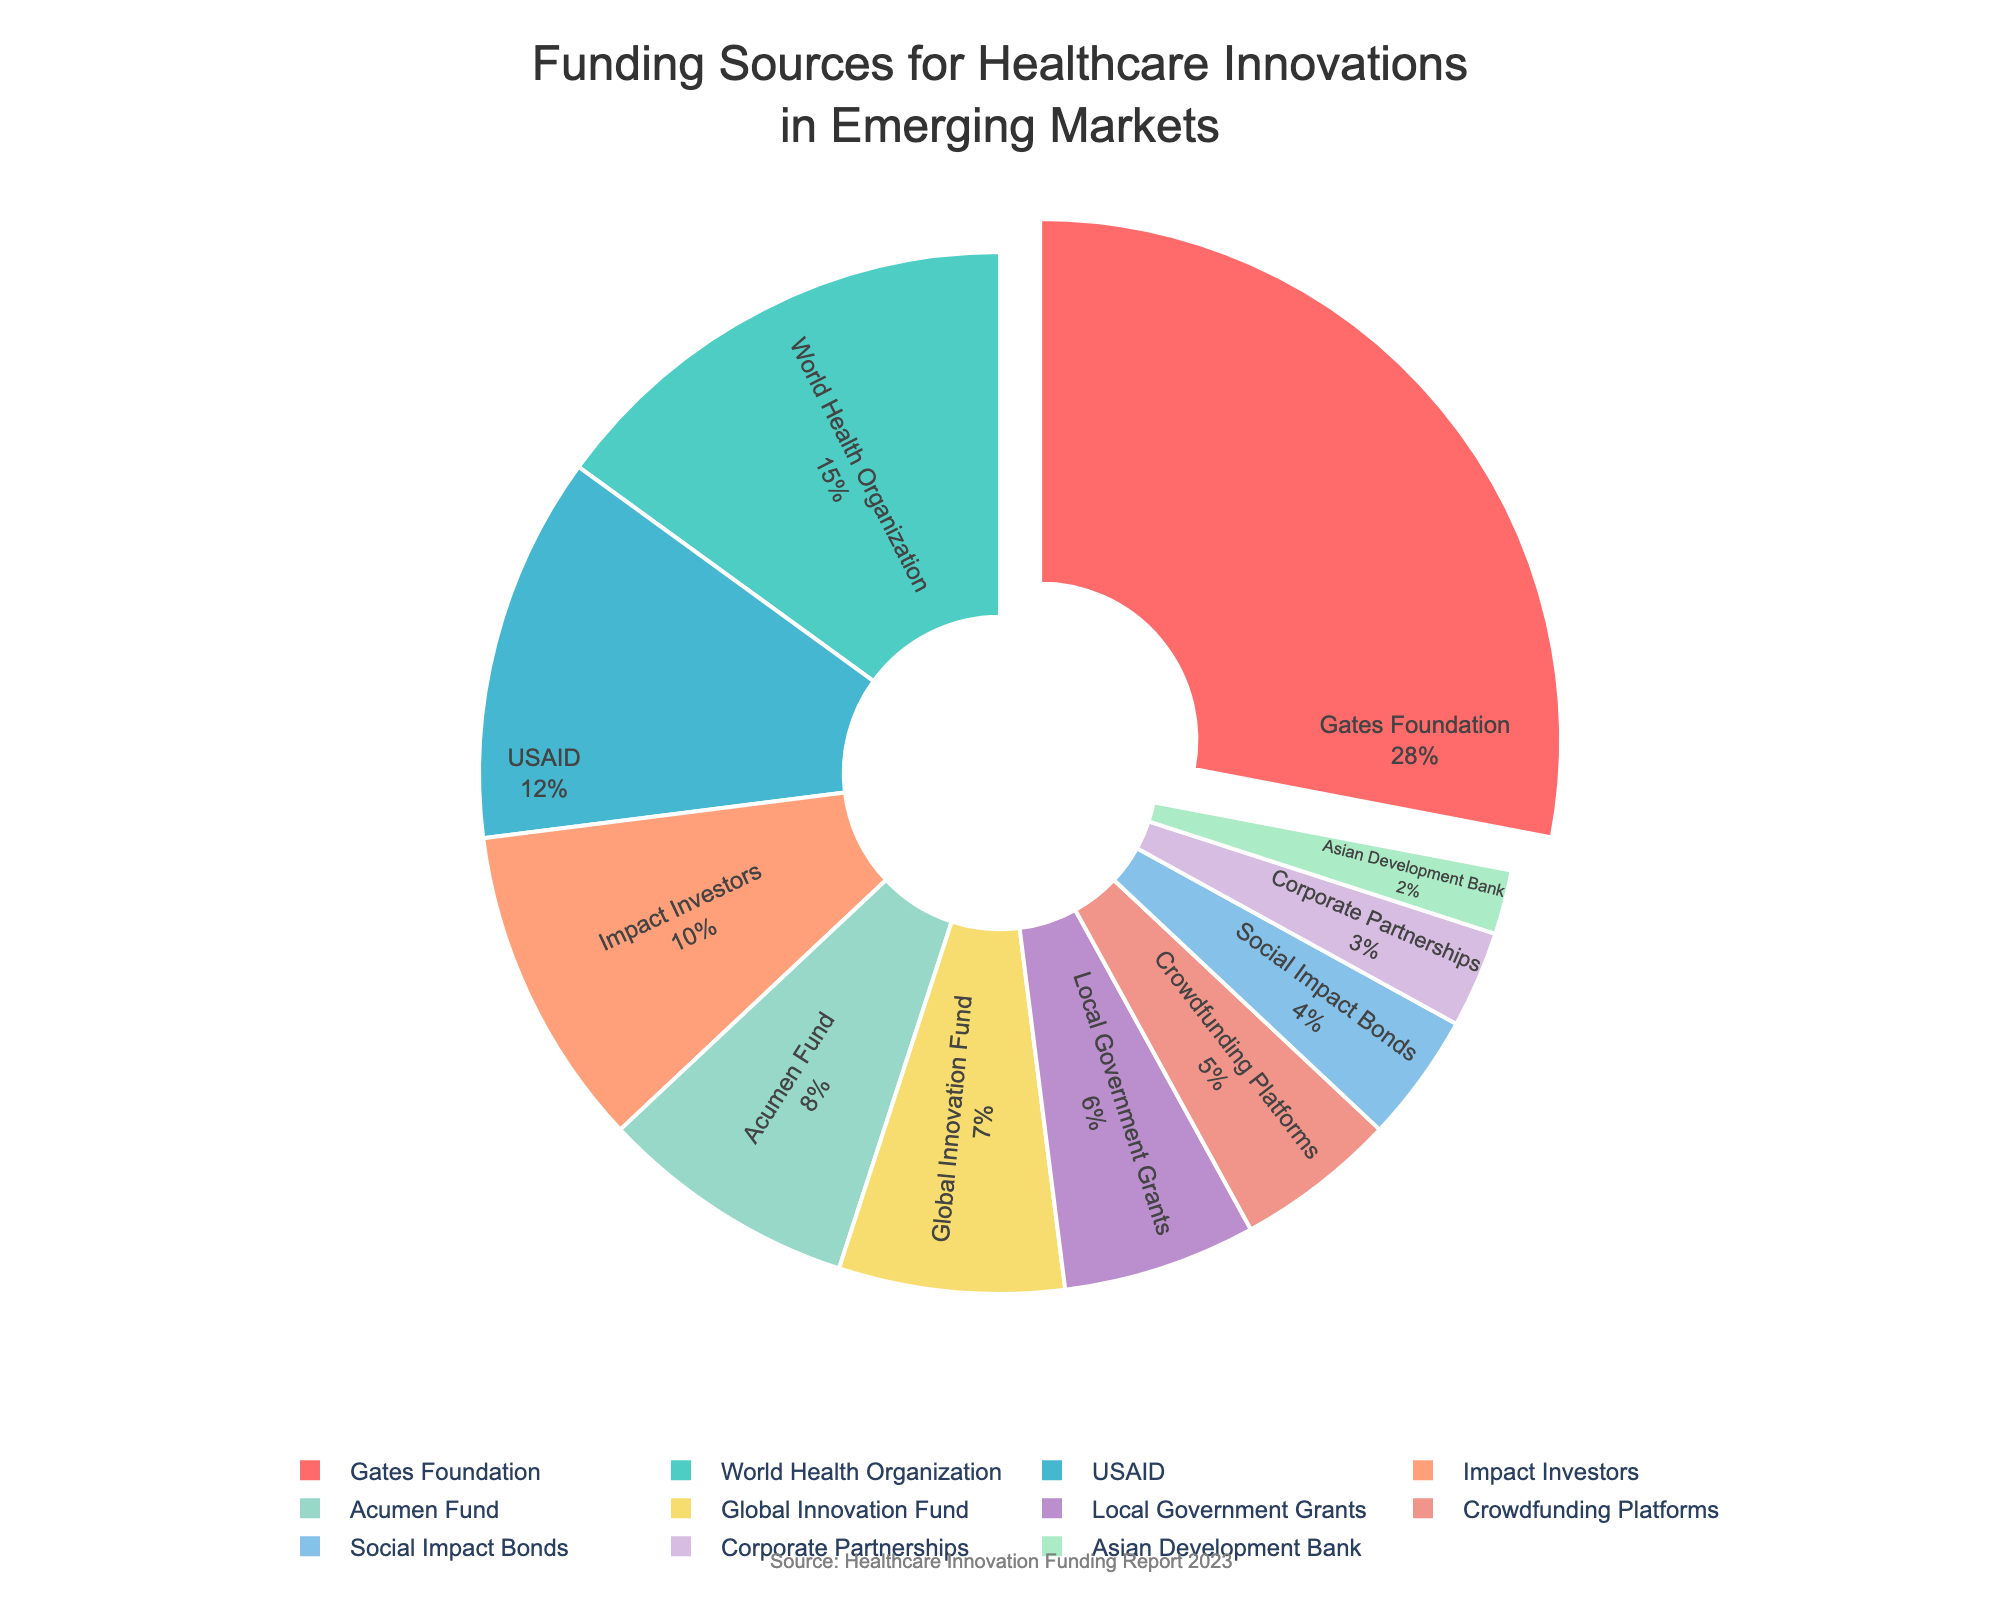What percentage of funding comes from the top three sources? To answer this, add the percentages for the top three funding sources: Gates Foundation (28%), World Health Organization (15%), and USAID (12%). The sum is 28 + 15 + 12 = 55%.
Answer: 55% Which funding source provides the least amount of funding? Look at the chart and identify the funding source with the smallest percentage. The Asian Development Bank has 2%, which is the smallest.
Answer: Asian Development Bank How much more funding does the Gates Foundation provide compared to Social Impact Bonds? Subtract the percentage of Social Impact Bonds from the percentage of Gates Foundation: 28% - 4% = 24%.
Answer: 24% What is the percentage of funding provided by non-governmental organizations (Gates Foundation, World Health Organization, USAID, Impact Investors, Acumen Fund)? Sum the percentages of these organizations: Gates Foundation (28%), World Health Organization (15%), USAID (12%), Impact Investors (10%), and Acumen Fund (8%). The total is 28 + 15 + 12 + 10 + 8 = 73%.
Answer: 73% If the total funding is $100 million, how much does the Global Innovation Fund contribute? Use the percentage for the Global Innovation Fund (7%). Calculate 7% of $100 million: 0.07 * 100,000,000 = $7,000,000.
Answer: $7,000,000 Which color represents the funding from Crowdfunding Platforms, and what percentage do they contribute? The color associated with Crowdfunding Platforms is observed to be a shade that matches the provided color scheme, which is '#F1948A'. The percentage is 5%.
Answer: Pink, 5% Is the funding from Local Government Grants more than that from Social Impact Bonds? Compare the percentages: Local Government Grants (6%) vs. Social Impact Bonds (4%). Since 6% is greater than 4%, the answer is yes.
Answer: Yes What is the combined funding percentage from Impact Investors, Acumen Fund, and Global Innovation Fund? Add the percentages of these three funding sources: Impact Investors (10%), Acumen Fund (8%), and Global Innovation Fund (7%). The total is 10 + 8 + 7 = 25%.
Answer: 25% How much less funding is provided by Corporate Partnerships compared to USAID? Subtract the percentage of Corporate Partnerships from the percentage of USAID: 12% - 3% = 9%.
Answer: 9% If we group the funding into those that give more than 10% and those that give 10% or less, how much is contributed by each group? Group 1: Gates Foundation (28%), World Health Organization (15%), and USAID (12%); Group 2: Impact Investors (10%), Acumen Fund (8%), Global Innovation Fund (7%), Local Government Grants (6%), Crowdfunding Platforms (5%), Social Impact Bonds (4%), Corporate Partnerships (3%), Asian Development Bank (2%). Sum for Group 1 is 28 + 15 + 12 = 55%. Sum for Group 2 is 10 + 8 + 7 + 6 + 5 + 4 + 3 + 2 = 35%.
Answer: Group 1: 55%, Group 2: 35% 